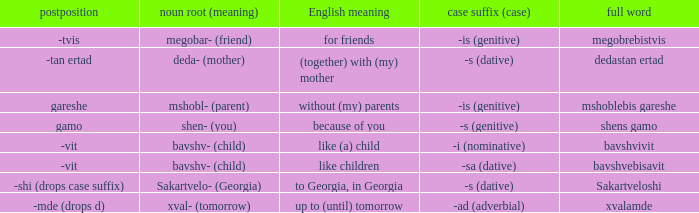Can you give me this table as a dict? {'header': ['postposition', 'noun root (meaning)', 'English meaning', 'case suffix (case)', 'full word'], 'rows': [['-tvis', 'megobar- (friend)', 'for friends', '-is (genitive)', 'megobrebistvis'], ['-tan ertad', 'deda- (mother)', '(together) with (my) mother', '-s (dative)', 'dedastan ertad'], ['gareshe', 'mshobl- (parent)', 'without (my) parents', '-is (genitive)', 'mshoblebis gareshe'], ['gamo', 'shen- (you)', 'because of you', '-s (genitive)', 'shens gamo'], ['-vit', 'bavshv- (child)', 'like (a) child', '-i (nominative)', 'bavshvivit'], ['-vit', 'bavshv- (child)', 'like children', '-sa (dative)', 'bavshvebisavit'], ['-shi (drops case suffix)', 'Sakartvelo- (Georgia)', 'to Georgia, in Georgia', '-s (dative)', 'Sakartveloshi'], ['-mde (drops d)', 'xval- (tomorrow)', 'up to (until) tomorrow', '-ad (adverbial)', 'xvalamde']]} What is English Meaning, when Full Word is "Shens Gamo"? Because of you. 